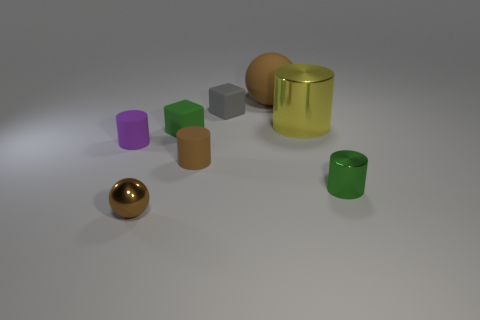What number of objects are brown matte blocks or tiny rubber things that are in front of the big metallic cylinder?
Your answer should be compact. 3. Are there more tiny brown matte cylinders on the right side of the yellow metal object than yellow cylinders that are on the left side of the tiny purple thing?
Offer a very short reply. No. What is the shape of the tiny rubber thing behind the green thing that is left of the small cylinder that is right of the small brown rubber cylinder?
Provide a short and direct response. Cube. What is the shape of the small green thing that is behind the thing on the left side of the metal ball?
Your answer should be compact. Cube. Are there any tiny things made of the same material as the purple cylinder?
Provide a succinct answer. Yes. What is the size of the matte cylinder that is the same color as the small shiny sphere?
Provide a short and direct response. Small. How many gray things are either shiny cylinders or tiny things?
Give a very brief answer. 1. Are there any big matte things that have the same color as the small ball?
Your answer should be very brief. Yes. What is the size of the brown sphere that is made of the same material as the brown cylinder?
Offer a terse response. Large. What number of blocks are large metallic things or small green shiny objects?
Give a very brief answer. 0. 